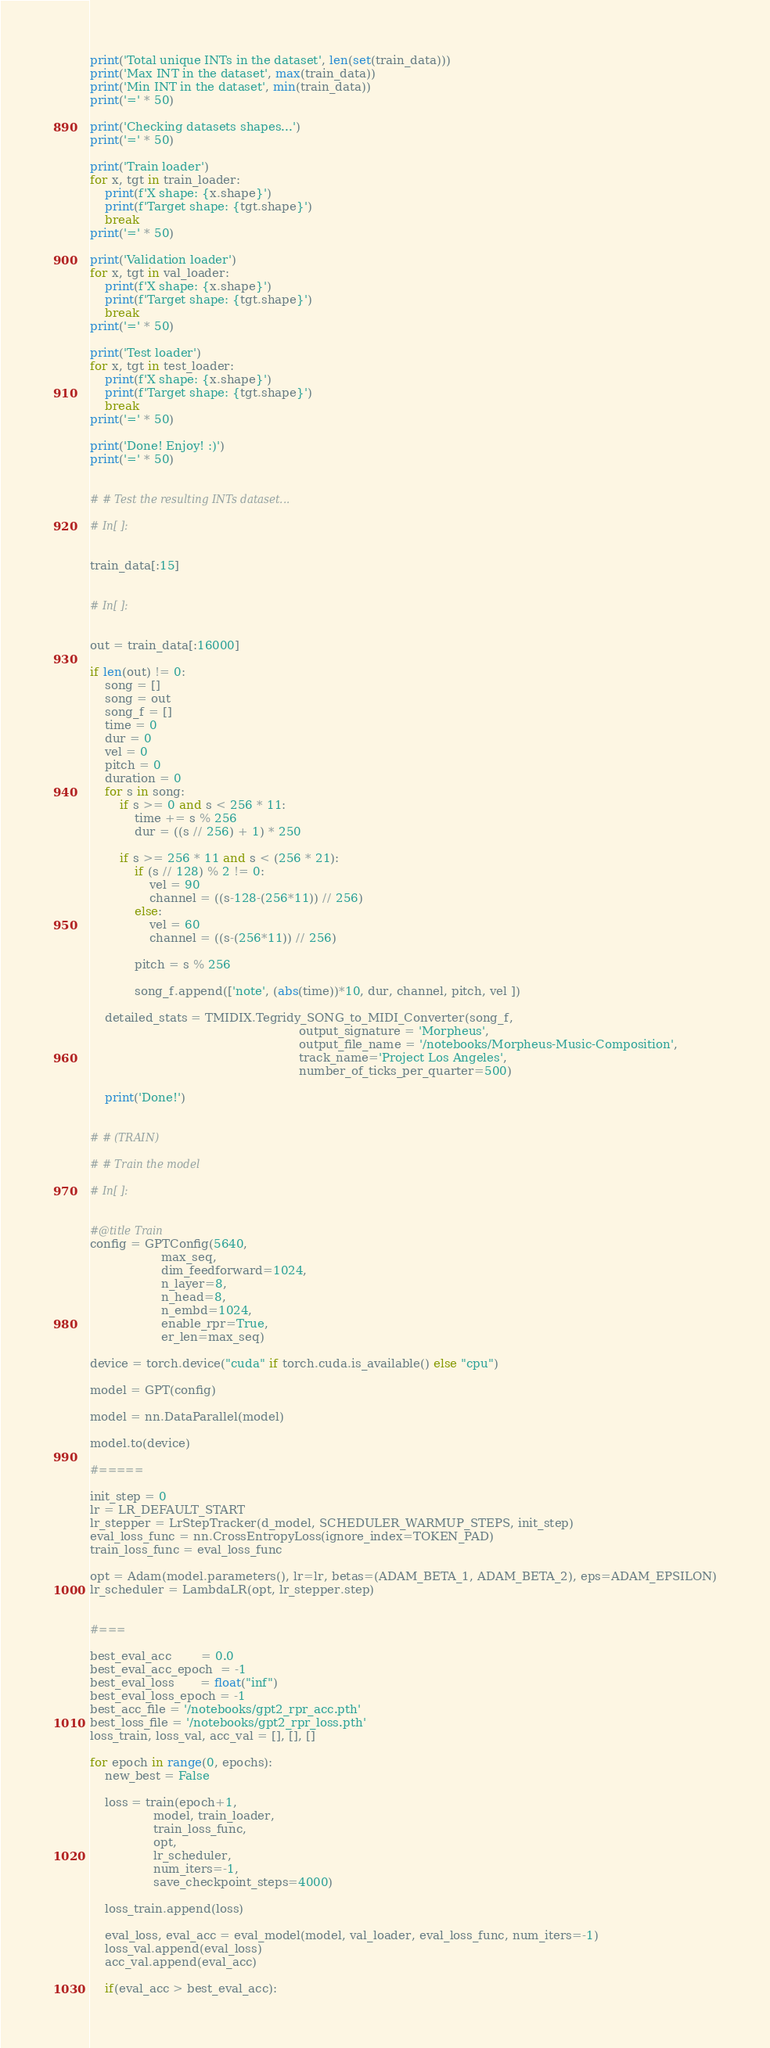<code> <loc_0><loc_0><loc_500><loc_500><_Python_>print('Total unique INTs in the dataset', len(set(train_data)))
print('Max INT in the dataset', max(train_data))
print('Min INT in the dataset', min(train_data))
print('=' * 50)

print('Checking datasets shapes...')
print('=' * 50)

print('Train loader')
for x, tgt in train_loader:
    print(f'X shape: {x.shape}')
    print(f'Target shape: {tgt.shape}')
    break
print('=' * 50)

print('Validation loader')
for x, tgt in val_loader:
    print(f'X shape: {x.shape}')
    print(f'Target shape: {tgt.shape}')
    break
print('=' * 50)

print('Test loader')
for x, tgt in test_loader:
    print(f'X shape: {x.shape}')
    print(f'Target shape: {tgt.shape}')
    break
print('=' * 50)

print('Done! Enjoy! :)')
print('=' * 50)


# # Test the resulting INTs dataset...

# In[ ]:


train_data[:15]


# In[ ]:


out = train_data[:16000]

if len(out) != 0:
    song = []
    song = out
    song_f = []
    time = 0
    dur = 0
    vel = 0
    pitch = 0
    duration = 0
    for s in song:
        if s >= 0 and s < 256 * 11:
            time += s % 256
            dur = ((s // 256) + 1) * 250

        if s >= 256 * 11 and s < (256 * 21):
            if (s // 128) % 2 != 0:
                vel = 90
                channel = ((s-128-(256*11)) // 256)
            else:
                vel = 60
                channel = ((s-(256*11)) // 256)

            pitch = s % 256

            song_f.append(['note', (abs(time))*10, dur, channel, pitch, vel ])

    detailed_stats = TMIDIX.Tegridy_SONG_to_MIDI_Converter(song_f,
                                                        output_signature = 'Morpheus',  
                                                        output_file_name = '/notebooks/Morpheus-Music-Composition', 
                                                        track_name='Project Los Angeles', 
                                                        number_of_ticks_per_quarter=500)

    print('Done!')


# # (TRAIN)

# # Train the model

# In[ ]:


#@title Train
config = GPTConfig(5640, 
                   max_seq,
                   dim_feedforward=1024,
                   n_layer=8, 
                   n_head=8, 
                   n_embd=1024,
                   enable_rpr=True,
                   er_len=max_seq)

device = torch.device("cuda" if torch.cuda.is_available() else "cpu")

model = GPT(config)

model = nn.DataParallel(model)

model.to(device)

#=====

init_step = 0
lr = LR_DEFAULT_START
lr_stepper = LrStepTracker(d_model, SCHEDULER_WARMUP_STEPS, init_step)
eval_loss_func = nn.CrossEntropyLoss(ignore_index=TOKEN_PAD)
train_loss_func = eval_loss_func

opt = Adam(model.parameters(), lr=lr, betas=(ADAM_BETA_1, ADAM_BETA_2), eps=ADAM_EPSILON)
lr_scheduler = LambdaLR(opt, lr_stepper.step)


#===

best_eval_acc        = 0.0
best_eval_acc_epoch  = -1
best_eval_loss       = float("inf")
best_eval_loss_epoch = -1
best_acc_file = '/notebooks/gpt2_rpr_acc.pth'
best_loss_file = '/notebooks/gpt2_rpr_loss.pth'
loss_train, loss_val, acc_val = [], [], []

for epoch in range(0, epochs):
    new_best = False
    
    loss = train(epoch+1, 
                 model, train_loader, 
                 train_loss_func, 
                 opt, 
                 lr_scheduler, 
                 num_iters=-1, 
                 save_checkpoint_steps=4000)
    
    loss_train.append(loss)
    
    eval_loss, eval_acc = eval_model(model, val_loader, eval_loss_func, num_iters=-1)
    loss_val.append(eval_loss)
    acc_val.append(eval_acc)
    
    if(eval_acc > best_eval_acc):</code> 